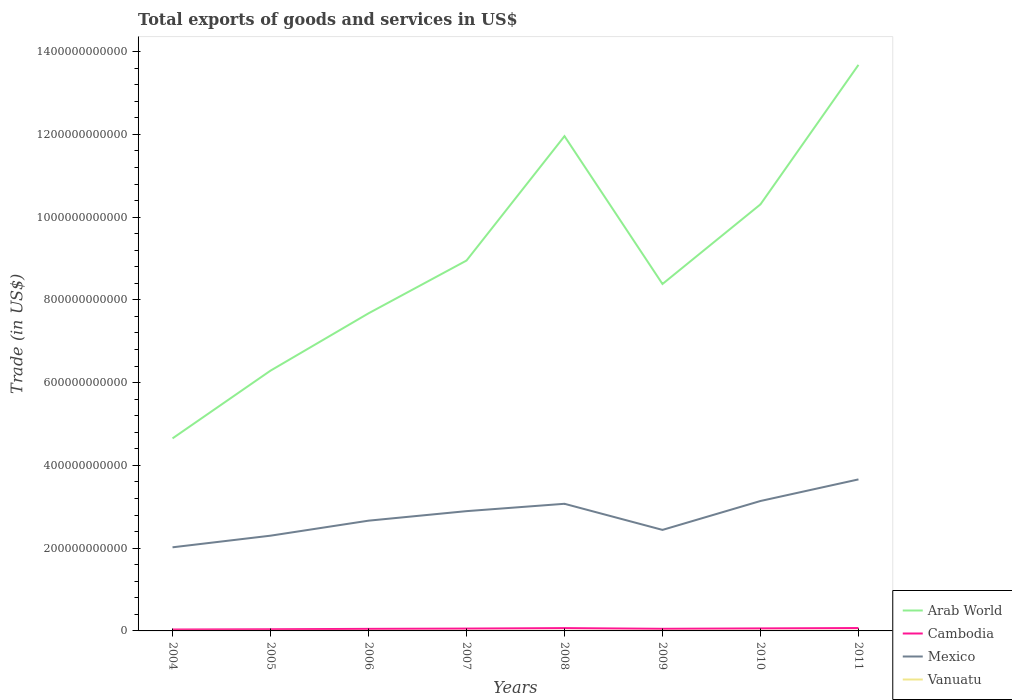Across all years, what is the maximum total exports of goods and services in Arab World?
Your answer should be very brief. 4.65e+11. In which year was the total exports of goods and services in Mexico maximum?
Your response must be concise. 2004. What is the total total exports of goods and services in Cambodia in the graph?
Keep it short and to the point. -1.53e+08. What is the difference between the highest and the second highest total exports of goods and services in Vanuatu?
Your answer should be very brief. 1.85e+08. Is the total exports of goods and services in Mexico strictly greater than the total exports of goods and services in Cambodia over the years?
Provide a succinct answer. No. What is the difference between two consecutive major ticks on the Y-axis?
Your answer should be very brief. 2.00e+11. Does the graph contain any zero values?
Your answer should be very brief. No. Does the graph contain grids?
Ensure brevity in your answer.  No. How many legend labels are there?
Ensure brevity in your answer.  4. How are the legend labels stacked?
Make the answer very short. Vertical. What is the title of the graph?
Make the answer very short. Total exports of goods and services in US$. Does "Egypt, Arab Rep." appear as one of the legend labels in the graph?
Keep it short and to the point. No. What is the label or title of the Y-axis?
Offer a very short reply. Trade (in US$). What is the Trade (in US$) in Arab World in 2004?
Provide a succinct answer. 4.65e+11. What is the Trade (in US$) of Cambodia in 2004?
Ensure brevity in your answer.  3.40e+09. What is the Trade (in US$) in Mexico in 2004?
Your answer should be very brief. 2.02e+11. What is the Trade (in US$) in Vanuatu in 2004?
Provide a succinct answer. 1.66e+08. What is the Trade (in US$) in Arab World in 2005?
Your answer should be compact. 6.29e+11. What is the Trade (in US$) of Cambodia in 2005?
Ensure brevity in your answer.  4.03e+09. What is the Trade (in US$) in Mexico in 2005?
Make the answer very short. 2.30e+11. What is the Trade (in US$) of Vanuatu in 2005?
Your answer should be very brief. 1.79e+08. What is the Trade (in US$) in Arab World in 2006?
Give a very brief answer. 7.67e+11. What is the Trade (in US$) in Cambodia in 2006?
Give a very brief answer. 4.99e+09. What is the Trade (in US$) of Mexico in 2006?
Offer a very short reply. 2.66e+11. What is the Trade (in US$) of Vanuatu in 2006?
Offer a terse response. 1.81e+08. What is the Trade (in US$) of Arab World in 2007?
Your answer should be very brief. 8.95e+11. What is the Trade (in US$) of Cambodia in 2007?
Make the answer very short. 5.64e+09. What is the Trade (in US$) of Mexico in 2007?
Provide a succinct answer. 2.89e+11. What is the Trade (in US$) in Vanuatu in 2007?
Ensure brevity in your answer.  2.15e+08. What is the Trade (in US$) of Arab World in 2008?
Offer a very short reply. 1.20e+12. What is the Trade (in US$) of Cambodia in 2008?
Keep it short and to the point. 6.78e+09. What is the Trade (in US$) in Mexico in 2008?
Provide a short and direct response. 3.07e+11. What is the Trade (in US$) of Vanuatu in 2008?
Give a very brief answer. 2.75e+08. What is the Trade (in US$) of Arab World in 2009?
Give a very brief answer. 8.38e+11. What is the Trade (in US$) in Cambodia in 2009?
Your answer should be compact. 5.12e+09. What is the Trade (in US$) of Mexico in 2009?
Provide a short and direct response. 2.44e+11. What is the Trade (in US$) of Vanuatu in 2009?
Offer a terse response. 3.00e+08. What is the Trade (in US$) in Arab World in 2010?
Keep it short and to the point. 1.03e+12. What is the Trade (in US$) of Cambodia in 2010?
Give a very brief answer. 6.08e+09. What is the Trade (in US$) of Mexico in 2010?
Provide a succinct answer. 3.14e+11. What is the Trade (in US$) in Vanuatu in 2010?
Make the answer very short. 3.27e+08. What is the Trade (in US$) in Arab World in 2011?
Ensure brevity in your answer.  1.37e+12. What is the Trade (in US$) in Cambodia in 2011?
Your answer should be very brief. 6.94e+09. What is the Trade (in US$) in Mexico in 2011?
Provide a short and direct response. 3.66e+11. What is the Trade (in US$) of Vanuatu in 2011?
Make the answer very short. 3.51e+08. Across all years, what is the maximum Trade (in US$) of Arab World?
Provide a short and direct response. 1.37e+12. Across all years, what is the maximum Trade (in US$) in Cambodia?
Give a very brief answer. 6.94e+09. Across all years, what is the maximum Trade (in US$) in Mexico?
Offer a very short reply. 3.66e+11. Across all years, what is the maximum Trade (in US$) in Vanuatu?
Keep it short and to the point. 3.51e+08. Across all years, what is the minimum Trade (in US$) in Arab World?
Your response must be concise. 4.65e+11. Across all years, what is the minimum Trade (in US$) of Cambodia?
Make the answer very short. 3.40e+09. Across all years, what is the minimum Trade (in US$) of Mexico?
Provide a succinct answer. 2.02e+11. Across all years, what is the minimum Trade (in US$) in Vanuatu?
Your answer should be compact. 1.66e+08. What is the total Trade (in US$) of Arab World in the graph?
Your response must be concise. 7.19e+12. What is the total Trade (in US$) of Cambodia in the graph?
Your answer should be very brief. 4.30e+1. What is the total Trade (in US$) in Mexico in the graph?
Your response must be concise. 2.22e+12. What is the total Trade (in US$) in Vanuatu in the graph?
Your answer should be compact. 1.99e+09. What is the difference between the Trade (in US$) of Arab World in 2004 and that in 2005?
Offer a terse response. -1.64e+11. What is the difference between the Trade (in US$) of Cambodia in 2004 and that in 2005?
Provide a short and direct response. -6.38e+08. What is the difference between the Trade (in US$) in Mexico in 2004 and that in 2005?
Ensure brevity in your answer.  -2.81e+1. What is the difference between the Trade (in US$) of Vanuatu in 2004 and that in 2005?
Offer a very short reply. -1.28e+07. What is the difference between the Trade (in US$) of Arab World in 2004 and that in 2006?
Ensure brevity in your answer.  -3.02e+11. What is the difference between the Trade (in US$) of Cambodia in 2004 and that in 2006?
Give a very brief answer. -1.59e+09. What is the difference between the Trade (in US$) in Mexico in 2004 and that in 2006?
Your answer should be compact. -6.44e+1. What is the difference between the Trade (in US$) of Vanuatu in 2004 and that in 2006?
Give a very brief answer. -1.49e+07. What is the difference between the Trade (in US$) in Arab World in 2004 and that in 2007?
Your answer should be compact. -4.30e+11. What is the difference between the Trade (in US$) in Cambodia in 2004 and that in 2007?
Provide a succinct answer. -2.25e+09. What is the difference between the Trade (in US$) in Mexico in 2004 and that in 2007?
Offer a very short reply. -8.74e+1. What is the difference between the Trade (in US$) of Vanuatu in 2004 and that in 2007?
Your response must be concise. -4.83e+07. What is the difference between the Trade (in US$) in Arab World in 2004 and that in 2008?
Ensure brevity in your answer.  -7.30e+11. What is the difference between the Trade (in US$) of Cambodia in 2004 and that in 2008?
Provide a succinct answer. -3.39e+09. What is the difference between the Trade (in US$) of Mexico in 2004 and that in 2008?
Keep it short and to the point. -1.05e+11. What is the difference between the Trade (in US$) in Vanuatu in 2004 and that in 2008?
Offer a very short reply. -1.08e+08. What is the difference between the Trade (in US$) of Arab World in 2004 and that in 2009?
Your answer should be very brief. -3.73e+11. What is the difference between the Trade (in US$) of Cambodia in 2004 and that in 2009?
Offer a terse response. -1.72e+09. What is the difference between the Trade (in US$) in Mexico in 2004 and that in 2009?
Your response must be concise. -4.21e+1. What is the difference between the Trade (in US$) in Vanuatu in 2004 and that in 2009?
Give a very brief answer. -1.33e+08. What is the difference between the Trade (in US$) in Arab World in 2004 and that in 2010?
Your answer should be very brief. -5.66e+11. What is the difference between the Trade (in US$) of Cambodia in 2004 and that in 2010?
Ensure brevity in your answer.  -2.68e+09. What is the difference between the Trade (in US$) of Mexico in 2004 and that in 2010?
Your answer should be compact. -1.12e+11. What is the difference between the Trade (in US$) of Vanuatu in 2004 and that in 2010?
Provide a short and direct response. -1.60e+08. What is the difference between the Trade (in US$) of Arab World in 2004 and that in 2011?
Provide a succinct answer. -9.03e+11. What is the difference between the Trade (in US$) in Cambodia in 2004 and that in 2011?
Your answer should be compact. -3.54e+09. What is the difference between the Trade (in US$) of Mexico in 2004 and that in 2011?
Give a very brief answer. -1.64e+11. What is the difference between the Trade (in US$) in Vanuatu in 2004 and that in 2011?
Make the answer very short. -1.85e+08. What is the difference between the Trade (in US$) of Arab World in 2005 and that in 2006?
Your answer should be compact. -1.39e+11. What is the difference between the Trade (in US$) in Cambodia in 2005 and that in 2006?
Your answer should be compact. -9.57e+08. What is the difference between the Trade (in US$) of Mexico in 2005 and that in 2006?
Keep it short and to the point. -3.63e+1. What is the difference between the Trade (in US$) in Vanuatu in 2005 and that in 2006?
Your answer should be very brief. -2.09e+06. What is the difference between the Trade (in US$) of Arab World in 2005 and that in 2007?
Offer a terse response. -2.66e+11. What is the difference between the Trade (in US$) in Cambodia in 2005 and that in 2007?
Make the answer very short. -1.61e+09. What is the difference between the Trade (in US$) of Mexico in 2005 and that in 2007?
Keep it short and to the point. -5.93e+1. What is the difference between the Trade (in US$) of Vanuatu in 2005 and that in 2007?
Provide a succinct answer. -3.55e+07. What is the difference between the Trade (in US$) of Arab World in 2005 and that in 2008?
Make the answer very short. -5.67e+11. What is the difference between the Trade (in US$) in Cambodia in 2005 and that in 2008?
Give a very brief answer. -2.75e+09. What is the difference between the Trade (in US$) of Mexico in 2005 and that in 2008?
Your answer should be compact. -7.71e+1. What is the difference between the Trade (in US$) of Vanuatu in 2005 and that in 2008?
Your answer should be very brief. -9.53e+07. What is the difference between the Trade (in US$) of Arab World in 2005 and that in 2009?
Offer a very short reply. -2.09e+11. What is the difference between the Trade (in US$) in Cambodia in 2005 and that in 2009?
Your response must be concise. -1.09e+09. What is the difference between the Trade (in US$) of Mexico in 2005 and that in 2009?
Make the answer very short. -1.40e+1. What is the difference between the Trade (in US$) in Vanuatu in 2005 and that in 2009?
Your response must be concise. -1.20e+08. What is the difference between the Trade (in US$) of Arab World in 2005 and that in 2010?
Provide a short and direct response. -4.02e+11. What is the difference between the Trade (in US$) of Cambodia in 2005 and that in 2010?
Your response must be concise. -2.05e+09. What is the difference between the Trade (in US$) in Mexico in 2005 and that in 2010?
Make the answer very short. -8.38e+1. What is the difference between the Trade (in US$) of Vanuatu in 2005 and that in 2010?
Provide a succinct answer. -1.48e+08. What is the difference between the Trade (in US$) of Arab World in 2005 and that in 2011?
Make the answer very short. -7.39e+11. What is the difference between the Trade (in US$) in Cambodia in 2005 and that in 2011?
Keep it short and to the point. -2.91e+09. What is the difference between the Trade (in US$) in Mexico in 2005 and that in 2011?
Provide a succinct answer. -1.36e+11. What is the difference between the Trade (in US$) in Vanuatu in 2005 and that in 2011?
Offer a terse response. -1.72e+08. What is the difference between the Trade (in US$) in Arab World in 2006 and that in 2007?
Offer a terse response. -1.28e+11. What is the difference between the Trade (in US$) of Cambodia in 2006 and that in 2007?
Your answer should be very brief. -6.54e+08. What is the difference between the Trade (in US$) in Mexico in 2006 and that in 2007?
Your answer should be very brief. -2.30e+1. What is the difference between the Trade (in US$) in Vanuatu in 2006 and that in 2007?
Provide a succinct answer. -3.34e+07. What is the difference between the Trade (in US$) in Arab World in 2006 and that in 2008?
Ensure brevity in your answer.  -4.28e+11. What is the difference between the Trade (in US$) in Cambodia in 2006 and that in 2008?
Offer a terse response. -1.80e+09. What is the difference between the Trade (in US$) of Mexico in 2006 and that in 2008?
Your response must be concise. -4.08e+1. What is the difference between the Trade (in US$) in Vanuatu in 2006 and that in 2008?
Provide a short and direct response. -9.32e+07. What is the difference between the Trade (in US$) of Arab World in 2006 and that in 2009?
Your answer should be very brief. -7.09e+1. What is the difference between the Trade (in US$) in Cambodia in 2006 and that in 2009?
Offer a very short reply. -1.30e+08. What is the difference between the Trade (in US$) of Mexico in 2006 and that in 2009?
Make the answer very short. 2.23e+1. What is the difference between the Trade (in US$) of Vanuatu in 2006 and that in 2009?
Provide a succinct answer. -1.18e+08. What is the difference between the Trade (in US$) of Arab World in 2006 and that in 2010?
Offer a very short reply. -2.63e+11. What is the difference between the Trade (in US$) in Cambodia in 2006 and that in 2010?
Provide a short and direct response. -1.09e+09. What is the difference between the Trade (in US$) of Mexico in 2006 and that in 2010?
Provide a succinct answer. -4.76e+1. What is the difference between the Trade (in US$) in Vanuatu in 2006 and that in 2010?
Your answer should be compact. -1.45e+08. What is the difference between the Trade (in US$) of Arab World in 2006 and that in 2011?
Your response must be concise. -6.00e+11. What is the difference between the Trade (in US$) in Cambodia in 2006 and that in 2011?
Keep it short and to the point. -1.95e+09. What is the difference between the Trade (in US$) in Mexico in 2006 and that in 2011?
Ensure brevity in your answer.  -9.97e+1. What is the difference between the Trade (in US$) of Vanuatu in 2006 and that in 2011?
Your answer should be very brief. -1.70e+08. What is the difference between the Trade (in US$) in Arab World in 2007 and that in 2008?
Offer a terse response. -3.01e+11. What is the difference between the Trade (in US$) of Cambodia in 2007 and that in 2008?
Your answer should be compact. -1.14e+09. What is the difference between the Trade (in US$) of Mexico in 2007 and that in 2008?
Offer a terse response. -1.78e+1. What is the difference between the Trade (in US$) of Vanuatu in 2007 and that in 2008?
Make the answer very short. -5.98e+07. What is the difference between the Trade (in US$) in Arab World in 2007 and that in 2009?
Offer a very short reply. 5.66e+1. What is the difference between the Trade (in US$) of Cambodia in 2007 and that in 2009?
Make the answer very short. 5.24e+08. What is the difference between the Trade (in US$) of Mexico in 2007 and that in 2009?
Provide a short and direct response. 4.53e+1. What is the difference between the Trade (in US$) in Vanuatu in 2007 and that in 2009?
Keep it short and to the point. -8.48e+07. What is the difference between the Trade (in US$) of Arab World in 2007 and that in 2010?
Offer a terse response. -1.36e+11. What is the difference between the Trade (in US$) of Cambodia in 2007 and that in 2010?
Provide a succinct answer. -4.36e+08. What is the difference between the Trade (in US$) in Mexico in 2007 and that in 2010?
Offer a terse response. -2.45e+1. What is the difference between the Trade (in US$) in Vanuatu in 2007 and that in 2010?
Provide a short and direct response. -1.12e+08. What is the difference between the Trade (in US$) of Arab World in 2007 and that in 2011?
Provide a succinct answer. -4.73e+11. What is the difference between the Trade (in US$) in Cambodia in 2007 and that in 2011?
Offer a very short reply. -1.29e+09. What is the difference between the Trade (in US$) in Mexico in 2007 and that in 2011?
Keep it short and to the point. -7.67e+1. What is the difference between the Trade (in US$) of Vanuatu in 2007 and that in 2011?
Offer a terse response. -1.36e+08. What is the difference between the Trade (in US$) of Arab World in 2008 and that in 2009?
Provide a short and direct response. 3.57e+11. What is the difference between the Trade (in US$) of Cambodia in 2008 and that in 2009?
Provide a short and direct response. 1.67e+09. What is the difference between the Trade (in US$) in Mexico in 2008 and that in 2009?
Ensure brevity in your answer.  6.31e+1. What is the difference between the Trade (in US$) in Vanuatu in 2008 and that in 2009?
Keep it short and to the point. -2.50e+07. What is the difference between the Trade (in US$) of Arab World in 2008 and that in 2010?
Your answer should be compact. 1.65e+11. What is the difference between the Trade (in US$) in Cambodia in 2008 and that in 2010?
Ensure brevity in your answer.  7.05e+08. What is the difference between the Trade (in US$) of Mexico in 2008 and that in 2010?
Your answer should be compact. -6.75e+09. What is the difference between the Trade (in US$) of Vanuatu in 2008 and that in 2010?
Keep it short and to the point. -5.22e+07. What is the difference between the Trade (in US$) of Arab World in 2008 and that in 2011?
Offer a very short reply. -1.72e+11. What is the difference between the Trade (in US$) of Cambodia in 2008 and that in 2011?
Give a very brief answer. -1.53e+08. What is the difference between the Trade (in US$) of Mexico in 2008 and that in 2011?
Make the answer very short. -5.89e+1. What is the difference between the Trade (in US$) in Vanuatu in 2008 and that in 2011?
Your answer should be compact. -7.67e+07. What is the difference between the Trade (in US$) in Arab World in 2009 and that in 2010?
Offer a terse response. -1.92e+11. What is the difference between the Trade (in US$) in Cambodia in 2009 and that in 2010?
Offer a terse response. -9.60e+08. What is the difference between the Trade (in US$) in Mexico in 2009 and that in 2010?
Ensure brevity in your answer.  -6.98e+1. What is the difference between the Trade (in US$) of Vanuatu in 2009 and that in 2010?
Provide a succinct answer. -2.72e+07. What is the difference between the Trade (in US$) of Arab World in 2009 and that in 2011?
Make the answer very short. -5.30e+11. What is the difference between the Trade (in US$) in Cambodia in 2009 and that in 2011?
Provide a short and direct response. -1.82e+09. What is the difference between the Trade (in US$) in Mexico in 2009 and that in 2011?
Keep it short and to the point. -1.22e+11. What is the difference between the Trade (in US$) in Vanuatu in 2009 and that in 2011?
Your response must be concise. -5.16e+07. What is the difference between the Trade (in US$) in Arab World in 2010 and that in 2011?
Your answer should be very brief. -3.37e+11. What is the difference between the Trade (in US$) of Cambodia in 2010 and that in 2011?
Ensure brevity in your answer.  -8.58e+08. What is the difference between the Trade (in US$) in Mexico in 2010 and that in 2011?
Give a very brief answer. -5.22e+1. What is the difference between the Trade (in US$) in Vanuatu in 2010 and that in 2011?
Offer a very short reply. -2.45e+07. What is the difference between the Trade (in US$) in Arab World in 2004 and the Trade (in US$) in Cambodia in 2005?
Provide a succinct answer. 4.61e+11. What is the difference between the Trade (in US$) in Arab World in 2004 and the Trade (in US$) in Mexico in 2005?
Your answer should be very brief. 2.35e+11. What is the difference between the Trade (in US$) of Arab World in 2004 and the Trade (in US$) of Vanuatu in 2005?
Offer a terse response. 4.65e+11. What is the difference between the Trade (in US$) in Cambodia in 2004 and the Trade (in US$) in Mexico in 2005?
Keep it short and to the point. -2.27e+11. What is the difference between the Trade (in US$) of Cambodia in 2004 and the Trade (in US$) of Vanuatu in 2005?
Provide a short and direct response. 3.22e+09. What is the difference between the Trade (in US$) of Mexico in 2004 and the Trade (in US$) of Vanuatu in 2005?
Your answer should be compact. 2.02e+11. What is the difference between the Trade (in US$) of Arab World in 2004 and the Trade (in US$) of Cambodia in 2006?
Offer a terse response. 4.60e+11. What is the difference between the Trade (in US$) of Arab World in 2004 and the Trade (in US$) of Mexico in 2006?
Your answer should be compact. 1.99e+11. What is the difference between the Trade (in US$) in Arab World in 2004 and the Trade (in US$) in Vanuatu in 2006?
Ensure brevity in your answer.  4.65e+11. What is the difference between the Trade (in US$) of Cambodia in 2004 and the Trade (in US$) of Mexico in 2006?
Offer a very short reply. -2.63e+11. What is the difference between the Trade (in US$) of Cambodia in 2004 and the Trade (in US$) of Vanuatu in 2006?
Make the answer very short. 3.21e+09. What is the difference between the Trade (in US$) of Mexico in 2004 and the Trade (in US$) of Vanuatu in 2006?
Your answer should be compact. 2.02e+11. What is the difference between the Trade (in US$) of Arab World in 2004 and the Trade (in US$) of Cambodia in 2007?
Offer a terse response. 4.60e+11. What is the difference between the Trade (in US$) of Arab World in 2004 and the Trade (in US$) of Mexico in 2007?
Offer a terse response. 1.76e+11. What is the difference between the Trade (in US$) of Arab World in 2004 and the Trade (in US$) of Vanuatu in 2007?
Offer a terse response. 4.65e+11. What is the difference between the Trade (in US$) in Cambodia in 2004 and the Trade (in US$) in Mexico in 2007?
Offer a very short reply. -2.86e+11. What is the difference between the Trade (in US$) in Cambodia in 2004 and the Trade (in US$) in Vanuatu in 2007?
Offer a very short reply. 3.18e+09. What is the difference between the Trade (in US$) of Mexico in 2004 and the Trade (in US$) of Vanuatu in 2007?
Your answer should be compact. 2.02e+11. What is the difference between the Trade (in US$) of Arab World in 2004 and the Trade (in US$) of Cambodia in 2008?
Offer a terse response. 4.58e+11. What is the difference between the Trade (in US$) of Arab World in 2004 and the Trade (in US$) of Mexico in 2008?
Provide a short and direct response. 1.58e+11. What is the difference between the Trade (in US$) of Arab World in 2004 and the Trade (in US$) of Vanuatu in 2008?
Give a very brief answer. 4.65e+11. What is the difference between the Trade (in US$) of Cambodia in 2004 and the Trade (in US$) of Mexico in 2008?
Provide a succinct answer. -3.04e+11. What is the difference between the Trade (in US$) in Cambodia in 2004 and the Trade (in US$) in Vanuatu in 2008?
Your answer should be very brief. 3.12e+09. What is the difference between the Trade (in US$) in Mexico in 2004 and the Trade (in US$) in Vanuatu in 2008?
Give a very brief answer. 2.02e+11. What is the difference between the Trade (in US$) of Arab World in 2004 and the Trade (in US$) of Cambodia in 2009?
Offer a terse response. 4.60e+11. What is the difference between the Trade (in US$) of Arab World in 2004 and the Trade (in US$) of Mexico in 2009?
Ensure brevity in your answer.  2.21e+11. What is the difference between the Trade (in US$) of Arab World in 2004 and the Trade (in US$) of Vanuatu in 2009?
Keep it short and to the point. 4.65e+11. What is the difference between the Trade (in US$) in Cambodia in 2004 and the Trade (in US$) in Mexico in 2009?
Keep it short and to the point. -2.41e+11. What is the difference between the Trade (in US$) of Cambodia in 2004 and the Trade (in US$) of Vanuatu in 2009?
Your answer should be compact. 3.10e+09. What is the difference between the Trade (in US$) in Mexico in 2004 and the Trade (in US$) in Vanuatu in 2009?
Your answer should be very brief. 2.02e+11. What is the difference between the Trade (in US$) in Arab World in 2004 and the Trade (in US$) in Cambodia in 2010?
Make the answer very short. 4.59e+11. What is the difference between the Trade (in US$) of Arab World in 2004 and the Trade (in US$) of Mexico in 2010?
Your answer should be very brief. 1.51e+11. What is the difference between the Trade (in US$) of Arab World in 2004 and the Trade (in US$) of Vanuatu in 2010?
Give a very brief answer. 4.65e+11. What is the difference between the Trade (in US$) in Cambodia in 2004 and the Trade (in US$) in Mexico in 2010?
Provide a succinct answer. -3.11e+11. What is the difference between the Trade (in US$) in Cambodia in 2004 and the Trade (in US$) in Vanuatu in 2010?
Keep it short and to the point. 3.07e+09. What is the difference between the Trade (in US$) of Mexico in 2004 and the Trade (in US$) of Vanuatu in 2010?
Your response must be concise. 2.02e+11. What is the difference between the Trade (in US$) of Arab World in 2004 and the Trade (in US$) of Cambodia in 2011?
Make the answer very short. 4.58e+11. What is the difference between the Trade (in US$) of Arab World in 2004 and the Trade (in US$) of Mexico in 2011?
Provide a succinct answer. 9.91e+1. What is the difference between the Trade (in US$) in Arab World in 2004 and the Trade (in US$) in Vanuatu in 2011?
Offer a terse response. 4.65e+11. What is the difference between the Trade (in US$) in Cambodia in 2004 and the Trade (in US$) in Mexico in 2011?
Your response must be concise. -3.63e+11. What is the difference between the Trade (in US$) in Cambodia in 2004 and the Trade (in US$) in Vanuatu in 2011?
Your answer should be very brief. 3.04e+09. What is the difference between the Trade (in US$) in Mexico in 2004 and the Trade (in US$) in Vanuatu in 2011?
Your answer should be compact. 2.02e+11. What is the difference between the Trade (in US$) of Arab World in 2005 and the Trade (in US$) of Cambodia in 2006?
Give a very brief answer. 6.24e+11. What is the difference between the Trade (in US$) in Arab World in 2005 and the Trade (in US$) in Mexico in 2006?
Keep it short and to the point. 3.63e+11. What is the difference between the Trade (in US$) of Arab World in 2005 and the Trade (in US$) of Vanuatu in 2006?
Ensure brevity in your answer.  6.29e+11. What is the difference between the Trade (in US$) in Cambodia in 2005 and the Trade (in US$) in Mexico in 2006?
Offer a terse response. -2.62e+11. What is the difference between the Trade (in US$) of Cambodia in 2005 and the Trade (in US$) of Vanuatu in 2006?
Your answer should be very brief. 3.85e+09. What is the difference between the Trade (in US$) in Mexico in 2005 and the Trade (in US$) in Vanuatu in 2006?
Keep it short and to the point. 2.30e+11. What is the difference between the Trade (in US$) of Arab World in 2005 and the Trade (in US$) of Cambodia in 2007?
Keep it short and to the point. 6.23e+11. What is the difference between the Trade (in US$) in Arab World in 2005 and the Trade (in US$) in Mexico in 2007?
Your answer should be compact. 3.40e+11. What is the difference between the Trade (in US$) of Arab World in 2005 and the Trade (in US$) of Vanuatu in 2007?
Your answer should be very brief. 6.29e+11. What is the difference between the Trade (in US$) of Cambodia in 2005 and the Trade (in US$) of Mexico in 2007?
Your response must be concise. -2.85e+11. What is the difference between the Trade (in US$) in Cambodia in 2005 and the Trade (in US$) in Vanuatu in 2007?
Keep it short and to the point. 3.82e+09. What is the difference between the Trade (in US$) in Mexico in 2005 and the Trade (in US$) in Vanuatu in 2007?
Your response must be concise. 2.30e+11. What is the difference between the Trade (in US$) of Arab World in 2005 and the Trade (in US$) of Cambodia in 2008?
Offer a very short reply. 6.22e+11. What is the difference between the Trade (in US$) in Arab World in 2005 and the Trade (in US$) in Mexico in 2008?
Offer a very short reply. 3.22e+11. What is the difference between the Trade (in US$) in Arab World in 2005 and the Trade (in US$) in Vanuatu in 2008?
Make the answer very short. 6.29e+11. What is the difference between the Trade (in US$) of Cambodia in 2005 and the Trade (in US$) of Mexico in 2008?
Offer a terse response. -3.03e+11. What is the difference between the Trade (in US$) of Cambodia in 2005 and the Trade (in US$) of Vanuatu in 2008?
Your answer should be compact. 3.76e+09. What is the difference between the Trade (in US$) of Mexico in 2005 and the Trade (in US$) of Vanuatu in 2008?
Provide a short and direct response. 2.30e+11. What is the difference between the Trade (in US$) of Arab World in 2005 and the Trade (in US$) of Cambodia in 2009?
Provide a short and direct response. 6.24e+11. What is the difference between the Trade (in US$) of Arab World in 2005 and the Trade (in US$) of Mexico in 2009?
Provide a short and direct response. 3.85e+11. What is the difference between the Trade (in US$) of Arab World in 2005 and the Trade (in US$) of Vanuatu in 2009?
Provide a short and direct response. 6.29e+11. What is the difference between the Trade (in US$) in Cambodia in 2005 and the Trade (in US$) in Mexico in 2009?
Your answer should be compact. -2.40e+11. What is the difference between the Trade (in US$) in Cambodia in 2005 and the Trade (in US$) in Vanuatu in 2009?
Make the answer very short. 3.73e+09. What is the difference between the Trade (in US$) of Mexico in 2005 and the Trade (in US$) of Vanuatu in 2009?
Your answer should be very brief. 2.30e+11. What is the difference between the Trade (in US$) of Arab World in 2005 and the Trade (in US$) of Cambodia in 2010?
Your answer should be very brief. 6.23e+11. What is the difference between the Trade (in US$) of Arab World in 2005 and the Trade (in US$) of Mexico in 2010?
Provide a succinct answer. 3.15e+11. What is the difference between the Trade (in US$) of Arab World in 2005 and the Trade (in US$) of Vanuatu in 2010?
Provide a succinct answer. 6.29e+11. What is the difference between the Trade (in US$) in Cambodia in 2005 and the Trade (in US$) in Mexico in 2010?
Your answer should be compact. -3.10e+11. What is the difference between the Trade (in US$) in Cambodia in 2005 and the Trade (in US$) in Vanuatu in 2010?
Make the answer very short. 3.71e+09. What is the difference between the Trade (in US$) in Mexico in 2005 and the Trade (in US$) in Vanuatu in 2010?
Offer a very short reply. 2.30e+11. What is the difference between the Trade (in US$) of Arab World in 2005 and the Trade (in US$) of Cambodia in 2011?
Your answer should be very brief. 6.22e+11. What is the difference between the Trade (in US$) in Arab World in 2005 and the Trade (in US$) in Mexico in 2011?
Keep it short and to the point. 2.63e+11. What is the difference between the Trade (in US$) of Arab World in 2005 and the Trade (in US$) of Vanuatu in 2011?
Ensure brevity in your answer.  6.29e+11. What is the difference between the Trade (in US$) in Cambodia in 2005 and the Trade (in US$) in Mexico in 2011?
Your response must be concise. -3.62e+11. What is the difference between the Trade (in US$) of Cambodia in 2005 and the Trade (in US$) of Vanuatu in 2011?
Provide a succinct answer. 3.68e+09. What is the difference between the Trade (in US$) of Mexico in 2005 and the Trade (in US$) of Vanuatu in 2011?
Your response must be concise. 2.30e+11. What is the difference between the Trade (in US$) in Arab World in 2006 and the Trade (in US$) in Cambodia in 2007?
Your answer should be compact. 7.62e+11. What is the difference between the Trade (in US$) of Arab World in 2006 and the Trade (in US$) of Mexico in 2007?
Provide a short and direct response. 4.78e+11. What is the difference between the Trade (in US$) of Arab World in 2006 and the Trade (in US$) of Vanuatu in 2007?
Your answer should be compact. 7.67e+11. What is the difference between the Trade (in US$) of Cambodia in 2006 and the Trade (in US$) of Mexico in 2007?
Your answer should be very brief. -2.84e+11. What is the difference between the Trade (in US$) of Cambodia in 2006 and the Trade (in US$) of Vanuatu in 2007?
Provide a succinct answer. 4.78e+09. What is the difference between the Trade (in US$) of Mexico in 2006 and the Trade (in US$) of Vanuatu in 2007?
Offer a very short reply. 2.66e+11. What is the difference between the Trade (in US$) of Arab World in 2006 and the Trade (in US$) of Cambodia in 2008?
Ensure brevity in your answer.  7.61e+11. What is the difference between the Trade (in US$) in Arab World in 2006 and the Trade (in US$) in Mexico in 2008?
Keep it short and to the point. 4.60e+11. What is the difference between the Trade (in US$) in Arab World in 2006 and the Trade (in US$) in Vanuatu in 2008?
Ensure brevity in your answer.  7.67e+11. What is the difference between the Trade (in US$) in Cambodia in 2006 and the Trade (in US$) in Mexico in 2008?
Your answer should be very brief. -3.02e+11. What is the difference between the Trade (in US$) of Cambodia in 2006 and the Trade (in US$) of Vanuatu in 2008?
Offer a very short reply. 4.72e+09. What is the difference between the Trade (in US$) of Mexico in 2006 and the Trade (in US$) of Vanuatu in 2008?
Provide a short and direct response. 2.66e+11. What is the difference between the Trade (in US$) in Arab World in 2006 and the Trade (in US$) in Cambodia in 2009?
Provide a short and direct response. 7.62e+11. What is the difference between the Trade (in US$) in Arab World in 2006 and the Trade (in US$) in Mexico in 2009?
Provide a succinct answer. 5.23e+11. What is the difference between the Trade (in US$) of Arab World in 2006 and the Trade (in US$) of Vanuatu in 2009?
Provide a succinct answer. 7.67e+11. What is the difference between the Trade (in US$) of Cambodia in 2006 and the Trade (in US$) of Mexico in 2009?
Make the answer very short. -2.39e+11. What is the difference between the Trade (in US$) of Cambodia in 2006 and the Trade (in US$) of Vanuatu in 2009?
Your response must be concise. 4.69e+09. What is the difference between the Trade (in US$) in Mexico in 2006 and the Trade (in US$) in Vanuatu in 2009?
Give a very brief answer. 2.66e+11. What is the difference between the Trade (in US$) of Arab World in 2006 and the Trade (in US$) of Cambodia in 2010?
Provide a succinct answer. 7.61e+11. What is the difference between the Trade (in US$) of Arab World in 2006 and the Trade (in US$) of Mexico in 2010?
Your answer should be compact. 4.53e+11. What is the difference between the Trade (in US$) of Arab World in 2006 and the Trade (in US$) of Vanuatu in 2010?
Your response must be concise. 7.67e+11. What is the difference between the Trade (in US$) in Cambodia in 2006 and the Trade (in US$) in Mexico in 2010?
Give a very brief answer. -3.09e+11. What is the difference between the Trade (in US$) in Cambodia in 2006 and the Trade (in US$) in Vanuatu in 2010?
Offer a terse response. 4.66e+09. What is the difference between the Trade (in US$) of Mexico in 2006 and the Trade (in US$) of Vanuatu in 2010?
Give a very brief answer. 2.66e+11. What is the difference between the Trade (in US$) of Arab World in 2006 and the Trade (in US$) of Cambodia in 2011?
Give a very brief answer. 7.61e+11. What is the difference between the Trade (in US$) in Arab World in 2006 and the Trade (in US$) in Mexico in 2011?
Your answer should be compact. 4.01e+11. What is the difference between the Trade (in US$) in Arab World in 2006 and the Trade (in US$) in Vanuatu in 2011?
Make the answer very short. 7.67e+11. What is the difference between the Trade (in US$) in Cambodia in 2006 and the Trade (in US$) in Mexico in 2011?
Provide a short and direct response. -3.61e+11. What is the difference between the Trade (in US$) in Cambodia in 2006 and the Trade (in US$) in Vanuatu in 2011?
Provide a short and direct response. 4.64e+09. What is the difference between the Trade (in US$) in Mexico in 2006 and the Trade (in US$) in Vanuatu in 2011?
Your answer should be very brief. 2.66e+11. What is the difference between the Trade (in US$) of Arab World in 2007 and the Trade (in US$) of Cambodia in 2008?
Your response must be concise. 8.88e+11. What is the difference between the Trade (in US$) of Arab World in 2007 and the Trade (in US$) of Mexico in 2008?
Your answer should be compact. 5.88e+11. What is the difference between the Trade (in US$) of Arab World in 2007 and the Trade (in US$) of Vanuatu in 2008?
Keep it short and to the point. 8.95e+11. What is the difference between the Trade (in US$) of Cambodia in 2007 and the Trade (in US$) of Mexico in 2008?
Keep it short and to the point. -3.02e+11. What is the difference between the Trade (in US$) in Cambodia in 2007 and the Trade (in US$) in Vanuatu in 2008?
Offer a terse response. 5.37e+09. What is the difference between the Trade (in US$) of Mexico in 2007 and the Trade (in US$) of Vanuatu in 2008?
Your answer should be very brief. 2.89e+11. What is the difference between the Trade (in US$) of Arab World in 2007 and the Trade (in US$) of Cambodia in 2009?
Ensure brevity in your answer.  8.90e+11. What is the difference between the Trade (in US$) in Arab World in 2007 and the Trade (in US$) in Mexico in 2009?
Your answer should be compact. 6.51e+11. What is the difference between the Trade (in US$) in Arab World in 2007 and the Trade (in US$) in Vanuatu in 2009?
Your response must be concise. 8.95e+11. What is the difference between the Trade (in US$) of Cambodia in 2007 and the Trade (in US$) of Mexico in 2009?
Ensure brevity in your answer.  -2.39e+11. What is the difference between the Trade (in US$) in Cambodia in 2007 and the Trade (in US$) in Vanuatu in 2009?
Your answer should be compact. 5.34e+09. What is the difference between the Trade (in US$) of Mexico in 2007 and the Trade (in US$) of Vanuatu in 2009?
Your answer should be compact. 2.89e+11. What is the difference between the Trade (in US$) of Arab World in 2007 and the Trade (in US$) of Cambodia in 2010?
Your response must be concise. 8.89e+11. What is the difference between the Trade (in US$) in Arab World in 2007 and the Trade (in US$) in Mexico in 2010?
Your answer should be compact. 5.81e+11. What is the difference between the Trade (in US$) in Arab World in 2007 and the Trade (in US$) in Vanuatu in 2010?
Make the answer very short. 8.95e+11. What is the difference between the Trade (in US$) in Cambodia in 2007 and the Trade (in US$) in Mexico in 2010?
Keep it short and to the point. -3.08e+11. What is the difference between the Trade (in US$) in Cambodia in 2007 and the Trade (in US$) in Vanuatu in 2010?
Provide a succinct answer. 5.32e+09. What is the difference between the Trade (in US$) in Mexico in 2007 and the Trade (in US$) in Vanuatu in 2010?
Offer a terse response. 2.89e+11. What is the difference between the Trade (in US$) of Arab World in 2007 and the Trade (in US$) of Cambodia in 2011?
Your response must be concise. 8.88e+11. What is the difference between the Trade (in US$) of Arab World in 2007 and the Trade (in US$) of Mexico in 2011?
Offer a terse response. 5.29e+11. What is the difference between the Trade (in US$) of Arab World in 2007 and the Trade (in US$) of Vanuatu in 2011?
Provide a short and direct response. 8.95e+11. What is the difference between the Trade (in US$) in Cambodia in 2007 and the Trade (in US$) in Mexico in 2011?
Provide a short and direct response. -3.61e+11. What is the difference between the Trade (in US$) in Cambodia in 2007 and the Trade (in US$) in Vanuatu in 2011?
Your answer should be compact. 5.29e+09. What is the difference between the Trade (in US$) in Mexico in 2007 and the Trade (in US$) in Vanuatu in 2011?
Provide a succinct answer. 2.89e+11. What is the difference between the Trade (in US$) in Arab World in 2008 and the Trade (in US$) in Cambodia in 2009?
Offer a very short reply. 1.19e+12. What is the difference between the Trade (in US$) in Arab World in 2008 and the Trade (in US$) in Mexico in 2009?
Give a very brief answer. 9.52e+11. What is the difference between the Trade (in US$) of Arab World in 2008 and the Trade (in US$) of Vanuatu in 2009?
Give a very brief answer. 1.20e+12. What is the difference between the Trade (in US$) of Cambodia in 2008 and the Trade (in US$) of Mexico in 2009?
Ensure brevity in your answer.  -2.37e+11. What is the difference between the Trade (in US$) in Cambodia in 2008 and the Trade (in US$) in Vanuatu in 2009?
Your answer should be very brief. 6.49e+09. What is the difference between the Trade (in US$) in Mexico in 2008 and the Trade (in US$) in Vanuatu in 2009?
Ensure brevity in your answer.  3.07e+11. What is the difference between the Trade (in US$) of Arab World in 2008 and the Trade (in US$) of Cambodia in 2010?
Your response must be concise. 1.19e+12. What is the difference between the Trade (in US$) of Arab World in 2008 and the Trade (in US$) of Mexico in 2010?
Provide a short and direct response. 8.82e+11. What is the difference between the Trade (in US$) of Arab World in 2008 and the Trade (in US$) of Vanuatu in 2010?
Offer a very short reply. 1.20e+12. What is the difference between the Trade (in US$) of Cambodia in 2008 and the Trade (in US$) of Mexico in 2010?
Provide a short and direct response. -3.07e+11. What is the difference between the Trade (in US$) in Cambodia in 2008 and the Trade (in US$) in Vanuatu in 2010?
Make the answer very short. 6.46e+09. What is the difference between the Trade (in US$) in Mexico in 2008 and the Trade (in US$) in Vanuatu in 2010?
Your answer should be compact. 3.07e+11. What is the difference between the Trade (in US$) in Arab World in 2008 and the Trade (in US$) in Cambodia in 2011?
Keep it short and to the point. 1.19e+12. What is the difference between the Trade (in US$) of Arab World in 2008 and the Trade (in US$) of Mexico in 2011?
Your answer should be very brief. 8.29e+11. What is the difference between the Trade (in US$) of Arab World in 2008 and the Trade (in US$) of Vanuatu in 2011?
Ensure brevity in your answer.  1.20e+12. What is the difference between the Trade (in US$) in Cambodia in 2008 and the Trade (in US$) in Mexico in 2011?
Give a very brief answer. -3.59e+11. What is the difference between the Trade (in US$) in Cambodia in 2008 and the Trade (in US$) in Vanuatu in 2011?
Give a very brief answer. 6.43e+09. What is the difference between the Trade (in US$) in Mexico in 2008 and the Trade (in US$) in Vanuatu in 2011?
Ensure brevity in your answer.  3.07e+11. What is the difference between the Trade (in US$) in Arab World in 2009 and the Trade (in US$) in Cambodia in 2010?
Your response must be concise. 8.32e+11. What is the difference between the Trade (in US$) in Arab World in 2009 and the Trade (in US$) in Mexico in 2010?
Keep it short and to the point. 5.24e+11. What is the difference between the Trade (in US$) of Arab World in 2009 and the Trade (in US$) of Vanuatu in 2010?
Provide a succinct answer. 8.38e+11. What is the difference between the Trade (in US$) in Cambodia in 2009 and the Trade (in US$) in Mexico in 2010?
Your answer should be very brief. -3.09e+11. What is the difference between the Trade (in US$) of Cambodia in 2009 and the Trade (in US$) of Vanuatu in 2010?
Your answer should be compact. 4.79e+09. What is the difference between the Trade (in US$) in Mexico in 2009 and the Trade (in US$) in Vanuatu in 2010?
Provide a succinct answer. 2.44e+11. What is the difference between the Trade (in US$) of Arab World in 2009 and the Trade (in US$) of Cambodia in 2011?
Your answer should be very brief. 8.31e+11. What is the difference between the Trade (in US$) in Arab World in 2009 and the Trade (in US$) in Mexico in 2011?
Your answer should be very brief. 4.72e+11. What is the difference between the Trade (in US$) in Arab World in 2009 and the Trade (in US$) in Vanuatu in 2011?
Keep it short and to the point. 8.38e+11. What is the difference between the Trade (in US$) of Cambodia in 2009 and the Trade (in US$) of Mexico in 2011?
Make the answer very short. -3.61e+11. What is the difference between the Trade (in US$) of Cambodia in 2009 and the Trade (in US$) of Vanuatu in 2011?
Give a very brief answer. 4.77e+09. What is the difference between the Trade (in US$) of Mexico in 2009 and the Trade (in US$) of Vanuatu in 2011?
Keep it short and to the point. 2.44e+11. What is the difference between the Trade (in US$) in Arab World in 2010 and the Trade (in US$) in Cambodia in 2011?
Offer a very short reply. 1.02e+12. What is the difference between the Trade (in US$) of Arab World in 2010 and the Trade (in US$) of Mexico in 2011?
Your answer should be compact. 6.65e+11. What is the difference between the Trade (in US$) of Arab World in 2010 and the Trade (in US$) of Vanuatu in 2011?
Your answer should be very brief. 1.03e+12. What is the difference between the Trade (in US$) of Cambodia in 2010 and the Trade (in US$) of Mexico in 2011?
Your answer should be compact. -3.60e+11. What is the difference between the Trade (in US$) of Cambodia in 2010 and the Trade (in US$) of Vanuatu in 2011?
Give a very brief answer. 5.73e+09. What is the difference between the Trade (in US$) of Mexico in 2010 and the Trade (in US$) of Vanuatu in 2011?
Your answer should be very brief. 3.14e+11. What is the average Trade (in US$) of Arab World per year?
Provide a short and direct response. 8.99e+11. What is the average Trade (in US$) of Cambodia per year?
Offer a very short reply. 5.37e+09. What is the average Trade (in US$) of Mexico per year?
Your answer should be very brief. 2.77e+11. What is the average Trade (in US$) in Vanuatu per year?
Your answer should be compact. 2.49e+08. In the year 2004, what is the difference between the Trade (in US$) in Arab World and Trade (in US$) in Cambodia?
Provide a succinct answer. 4.62e+11. In the year 2004, what is the difference between the Trade (in US$) of Arab World and Trade (in US$) of Mexico?
Give a very brief answer. 2.63e+11. In the year 2004, what is the difference between the Trade (in US$) in Arab World and Trade (in US$) in Vanuatu?
Offer a terse response. 4.65e+11. In the year 2004, what is the difference between the Trade (in US$) in Cambodia and Trade (in US$) in Mexico?
Your response must be concise. -1.99e+11. In the year 2004, what is the difference between the Trade (in US$) in Cambodia and Trade (in US$) in Vanuatu?
Offer a terse response. 3.23e+09. In the year 2004, what is the difference between the Trade (in US$) in Mexico and Trade (in US$) in Vanuatu?
Offer a terse response. 2.02e+11. In the year 2005, what is the difference between the Trade (in US$) in Arab World and Trade (in US$) in Cambodia?
Keep it short and to the point. 6.25e+11. In the year 2005, what is the difference between the Trade (in US$) in Arab World and Trade (in US$) in Mexico?
Offer a terse response. 3.99e+11. In the year 2005, what is the difference between the Trade (in US$) in Arab World and Trade (in US$) in Vanuatu?
Give a very brief answer. 6.29e+11. In the year 2005, what is the difference between the Trade (in US$) in Cambodia and Trade (in US$) in Mexico?
Ensure brevity in your answer.  -2.26e+11. In the year 2005, what is the difference between the Trade (in US$) of Cambodia and Trade (in US$) of Vanuatu?
Keep it short and to the point. 3.85e+09. In the year 2005, what is the difference between the Trade (in US$) in Mexico and Trade (in US$) in Vanuatu?
Offer a terse response. 2.30e+11. In the year 2006, what is the difference between the Trade (in US$) in Arab World and Trade (in US$) in Cambodia?
Keep it short and to the point. 7.62e+11. In the year 2006, what is the difference between the Trade (in US$) of Arab World and Trade (in US$) of Mexico?
Ensure brevity in your answer.  5.01e+11. In the year 2006, what is the difference between the Trade (in US$) in Arab World and Trade (in US$) in Vanuatu?
Ensure brevity in your answer.  7.67e+11. In the year 2006, what is the difference between the Trade (in US$) in Cambodia and Trade (in US$) in Mexico?
Ensure brevity in your answer.  -2.61e+11. In the year 2006, what is the difference between the Trade (in US$) in Cambodia and Trade (in US$) in Vanuatu?
Give a very brief answer. 4.81e+09. In the year 2006, what is the difference between the Trade (in US$) in Mexico and Trade (in US$) in Vanuatu?
Your response must be concise. 2.66e+11. In the year 2007, what is the difference between the Trade (in US$) of Arab World and Trade (in US$) of Cambodia?
Make the answer very short. 8.89e+11. In the year 2007, what is the difference between the Trade (in US$) of Arab World and Trade (in US$) of Mexico?
Your answer should be compact. 6.06e+11. In the year 2007, what is the difference between the Trade (in US$) in Arab World and Trade (in US$) in Vanuatu?
Your answer should be compact. 8.95e+11. In the year 2007, what is the difference between the Trade (in US$) of Cambodia and Trade (in US$) of Mexico?
Keep it short and to the point. -2.84e+11. In the year 2007, what is the difference between the Trade (in US$) of Cambodia and Trade (in US$) of Vanuatu?
Your answer should be compact. 5.43e+09. In the year 2007, what is the difference between the Trade (in US$) of Mexico and Trade (in US$) of Vanuatu?
Your answer should be compact. 2.89e+11. In the year 2008, what is the difference between the Trade (in US$) in Arab World and Trade (in US$) in Cambodia?
Give a very brief answer. 1.19e+12. In the year 2008, what is the difference between the Trade (in US$) of Arab World and Trade (in US$) of Mexico?
Keep it short and to the point. 8.88e+11. In the year 2008, what is the difference between the Trade (in US$) of Arab World and Trade (in US$) of Vanuatu?
Keep it short and to the point. 1.20e+12. In the year 2008, what is the difference between the Trade (in US$) of Cambodia and Trade (in US$) of Mexico?
Make the answer very short. -3.00e+11. In the year 2008, what is the difference between the Trade (in US$) in Cambodia and Trade (in US$) in Vanuatu?
Your answer should be very brief. 6.51e+09. In the year 2008, what is the difference between the Trade (in US$) of Mexico and Trade (in US$) of Vanuatu?
Ensure brevity in your answer.  3.07e+11. In the year 2009, what is the difference between the Trade (in US$) of Arab World and Trade (in US$) of Cambodia?
Your answer should be compact. 8.33e+11. In the year 2009, what is the difference between the Trade (in US$) of Arab World and Trade (in US$) of Mexico?
Keep it short and to the point. 5.94e+11. In the year 2009, what is the difference between the Trade (in US$) of Arab World and Trade (in US$) of Vanuatu?
Offer a terse response. 8.38e+11. In the year 2009, what is the difference between the Trade (in US$) in Cambodia and Trade (in US$) in Mexico?
Offer a terse response. -2.39e+11. In the year 2009, what is the difference between the Trade (in US$) of Cambodia and Trade (in US$) of Vanuatu?
Provide a succinct answer. 4.82e+09. In the year 2009, what is the difference between the Trade (in US$) in Mexico and Trade (in US$) in Vanuatu?
Provide a succinct answer. 2.44e+11. In the year 2010, what is the difference between the Trade (in US$) of Arab World and Trade (in US$) of Cambodia?
Keep it short and to the point. 1.02e+12. In the year 2010, what is the difference between the Trade (in US$) in Arab World and Trade (in US$) in Mexico?
Provide a short and direct response. 7.17e+11. In the year 2010, what is the difference between the Trade (in US$) in Arab World and Trade (in US$) in Vanuatu?
Make the answer very short. 1.03e+12. In the year 2010, what is the difference between the Trade (in US$) of Cambodia and Trade (in US$) of Mexico?
Provide a short and direct response. -3.08e+11. In the year 2010, what is the difference between the Trade (in US$) of Cambodia and Trade (in US$) of Vanuatu?
Your response must be concise. 5.75e+09. In the year 2010, what is the difference between the Trade (in US$) in Mexico and Trade (in US$) in Vanuatu?
Your answer should be very brief. 3.14e+11. In the year 2011, what is the difference between the Trade (in US$) of Arab World and Trade (in US$) of Cambodia?
Your answer should be compact. 1.36e+12. In the year 2011, what is the difference between the Trade (in US$) in Arab World and Trade (in US$) in Mexico?
Ensure brevity in your answer.  1.00e+12. In the year 2011, what is the difference between the Trade (in US$) in Arab World and Trade (in US$) in Vanuatu?
Your response must be concise. 1.37e+12. In the year 2011, what is the difference between the Trade (in US$) in Cambodia and Trade (in US$) in Mexico?
Offer a very short reply. -3.59e+11. In the year 2011, what is the difference between the Trade (in US$) of Cambodia and Trade (in US$) of Vanuatu?
Offer a terse response. 6.59e+09. In the year 2011, what is the difference between the Trade (in US$) of Mexico and Trade (in US$) of Vanuatu?
Offer a terse response. 3.66e+11. What is the ratio of the Trade (in US$) of Arab World in 2004 to that in 2005?
Offer a terse response. 0.74. What is the ratio of the Trade (in US$) in Cambodia in 2004 to that in 2005?
Provide a short and direct response. 0.84. What is the ratio of the Trade (in US$) of Mexico in 2004 to that in 2005?
Provide a succinct answer. 0.88. What is the ratio of the Trade (in US$) in Vanuatu in 2004 to that in 2005?
Make the answer very short. 0.93. What is the ratio of the Trade (in US$) of Arab World in 2004 to that in 2006?
Give a very brief answer. 0.61. What is the ratio of the Trade (in US$) of Cambodia in 2004 to that in 2006?
Keep it short and to the point. 0.68. What is the ratio of the Trade (in US$) of Mexico in 2004 to that in 2006?
Ensure brevity in your answer.  0.76. What is the ratio of the Trade (in US$) in Vanuatu in 2004 to that in 2006?
Give a very brief answer. 0.92. What is the ratio of the Trade (in US$) of Arab World in 2004 to that in 2007?
Provide a short and direct response. 0.52. What is the ratio of the Trade (in US$) in Cambodia in 2004 to that in 2007?
Give a very brief answer. 0.6. What is the ratio of the Trade (in US$) in Mexico in 2004 to that in 2007?
Offer a terse response. 0.7. What is the ratio of the Trade (in US$) of Vanuatu in 2004 to that in 2007?
Offer a very short reply. 0.78. What is the ratio of the Trade (in US$) of Arab World in 2004 to that in 2008?
Your answer should be compact. 0.39. What is the ratio of the Trade (in US$) in Cambodia in 2004 to that in 2008?
Your answer should be very brief. 0.5. What is the ratio of the Trade (in US$) in Mexico in 2004 to that in 2008?
Provide a succinct answer. 0.66. What is the ratio of the Trade (in US$) of Vanuatu in 2004 to that in 2008?
Give a very brief answer. 0.61. What is the ratio of the Trade (in US$) of Arab World in 2004 to that in 2009?
Offer a terse response. 0.56. What is the ratio of the Trade (in US$) in Cambodia in 2004 to that in 2009?
Keep it short and to the point. 0.66. What is the ratio of the Trade (in US$) of Mexico in 2004 to that in 2009?
Provide a short and direct response. 0.83. What is the ratio of the Trade (in US$) of Vanuatu in 2004 to that in 2009?
Your response must be concise. 0.56. What is the ratio of the Trade (in US$) in Arab World in 2004 to that in 2010?
Offer a very short reply. 0.45. What is the ratio of the Trade (in US$) in Cambodia in 2004 to that in 2010?
Your answer should be very brief. 0.56. What is the ratio of the Trade (in US$) in Mexico in 2004 to that in 2010?
Offer a terse response. 0.64. What is the ratio of the Trade (in US$) in Vanuatu in 2004 to that in 2010?
Ensure brevity in your answer.  0.51. What is the ratio of the Trade (in US$) of Arab World in 2004 to that in 2011?
Offer a terse response. 0.34. What is the ratio of the Trade (in US$) of Cambodia in 2004 to that in 2011?
Keep it short and to the point. 0.49. What is the ratio of the Trade (in US$) of Mexico in 2004 to that in 2011?
Give a very brief answer. 0.55. What is the ratio of the Trade (in US$) in Vanuatu in 2004 to that in 2011?
Provide a succinct answer. 0.47. What is the ratio of the Trade (in US$) of Arab World in 2005 to that in 2006?
Make the answer very short. 0.82. What is the ratio of the Trade (in US$) in Cambodia in 2005 to that in 2006?
Offer a terse response. 0.81. What is the ratio of the Trade (in US$) in Mexico in 2005 to that in 2006?
Provide a short and direct response. 0.86. What is the ratio of the Trade (in US$) in Vanuatu in 2005 to that in 2006?
Offer a terse response. 0.99. What is the ratio of the Trade (in US$) in Arab World in 2005 to that in 2007?
Offer a very short reply. 0.7. What is the ratio of the Trade (in US$) in Cambodia in 2005 to that in 2007?
Offer a terse response. 0.71. What is the ratio of the Trade (in US$) of Mexico in 2005 to that in 2007?
Your response must be concise. 0.8. What is the ratio of the Trade (in US$) in Vanuatu in 2005 to that in 2007?
Your answer should be very brief. 0.83. What is the ratio of the Trade (in US$) of Arab World in 2005 to that in 2008?
Ensure brevity in your answer.  0.53. What is the ratio of the Trade (in US$) in Cambodia in 2005 to that in 2008?
Give a very brief answer. 0.59. What is the ratio of the Trade (in US$) in Mexico in 2005 to that in 2008?
Provide a short and direct response. 0.75. What is the ratio of the Trade (in US$) in Vanuatu in 2005 to that in 2008?
Offer a very short reply. 0.65. What is the ratio of the Trade (in US$) of Arab World in 2005 to that in 2009?
Give a very brief answer. 0.75. What is the ratio of the Trade (in US$) of Cambodia in 2005 to that in 2009?
Offer a terse response. 0.79. What is the ratio of the Trade (in US$) of Mexico in 2005 to that in 2009?
Your response must be concise. 0.94. What is the ratio of the Trade (in US$) in Vanuatu in 2005 to that in 2009?
Make the answer very short. 0.6. What is the ratio of the Trade (in US$) in Arab World in 2005 to that in 2010?
Offer a terse response. 0.61. What is the ratio of the Trade (in US$) of Cambodia in 2005 to that in 2010?
Offer a terse response. 0.66. What is the ratio of the Trade (in US$) of Mexico in 2005 to that in 2010?
Your response must be concise. 0.73. What is the ratio of the Trade (in US$) in Vanuatu in 2005 to that in 2010?
Ensure brevity in your answer.  0.55. What is the ratio of the Trade (in US$) of Arab World in 2005 to that in 2011?
Your response must be concise. 0.46. What is the ratio of the Trade (in US$) of Cambodia in 2005 to that in 2011?
Your answer should be very brief. 0.58. What is the ratio of the Trade (in US$) in Mexico in 2005 to that in 2011?
Make the answer very short. 0.63. What is the ratio of the Trade (in US$) of Vanuatu in 2005 to that in 2011?
Your response must be concise. 0.51. What is the ratio of the Trade (in US$) of Arab World in 2006 to that in 2007?
Keep it short and to the point. 0.86. What is the ratio of the Trade (in US$) of Cambodia in 2006 to that in 2007?
Give a very brief answer. 0.88. What is the ratio of the Trade (in US$) in Mexico in 2006 to that in 2007?
Keep it short and to the point. 0.92. What is the ratio of the Trade (in US$) of Vanuatu in 2006 to that in 2007?
Offer a terse response. 0.84. What is the ratio of the Trade (in US$) in Arab World in 2006 to that in 2008?
Give a very brief answer. 0.64. What is the ratio of the Trade (in US$) in Cambodia in 2006 to that in 2008?
Provide a short and direct response. 0.74. What is the ratio of the Trade (in US$) in Mexico in 2006 to that in 2008?
Make the answer very short. 0.87. What is the ratio of the Trade (in US$) in Vanuatu in 2006 to that in 2008?
Keep it short and to the point. 0.66. What is the ratio of the Trade (in US$) in Arab World in 2006 to that in 2009?
Offer a terse response. 0.92. What is the ratio of the Trade (in US$) of Cambodia in 2006 to that in 2009?
Offer a terse response. 0.97. What is the ratio of the Trade (in US$) of Mexico in 2006 to that in 2009?
Offer a very short reply. 1.09. What is the ratio of the Trade (in US$) of Vanuatu in 2006 to that in 2009?
Your answer should be compact. 0.61. What is the ratio of the Trade (in US$) in Arab World in 2006 to that in 2010?
Keep it short and to the point. 0.74. What is the ratio of the Trade (in US$) of Cambodia in 2006 to that in 2010?
Your answer should be very brief. 0.82. What is the ratio of the Trade (in US$) of Mexico in 2006 to that in 2010?
Your answer should be compact. 0.85. What is the ratio of the Trade (in US$) of Vanuatu in 2006 to that in 2010?
Provide a succinct answer. 0.55. What is the ratio of the Trade (in US$) of Arab World in 2006 to that in 2011?
Your response must be concise. 0.56. What is the ratio of the Trade (in US$) of Cambodia in 2006 to that in 2011?
Make the answer very short. 0.72. What is the ratio of the Trade (in US$) in Mexico in 2006 to that in 2011?
Make the answer very short. 0.73. What is the ratio of the Trade (in US$) in Vanuatu in 2006 to that in 2011?
Make the answer very short. 0.52. What is the ratio of the Trade (in US$) of Arab World in 2007 to that in 2008?
Ensure brevity in your answer.  0.75. What is the ratio of the Trade (in US$) of Cambodia in 2007 to that in 2008?
Keep it short and to the point. 0.83. What is the ratio of the Trade (in US$) in Mexico in 2007 to that in 2008?
Provide a succinct answer. 0.94. What is the ratio of the Trade (in US$) of Vanuatu in 2007 to that in 2008?
Make the answer very short. 0.78. What is the ratio of the Trade (in US$) of Arab World in 2007 to that in 2009?
Your response must be concise. 1.07. What is the ratio of the Trade (in US$) in Cambodia in 2007 to that in 2009?
Give a very brief answer. 1.1. What is the ratio of the Trade (in US$) of Mexico in 2007 to that in 2009?
Provide a short and direct response. 1.19. What is the ratio of the Trade (in US$) in Vanuatu in 2007 to that in 2009?
Give a very brief answer. 0.72. What is the ratio of the Trade (in US$) of Arab World in 2007 to that in 2010?
Your answer should be compact. 0.87. What is the ratio of the Trade (in US$) in Cambodia in 2007 to that in 2010?
Your answer should be very brief. 0.93. What is the ratio of the Trade (in US$) of Mexico in 2007 to that in 2010?
Offer a very short reply. 0.92. What is the ratio of the Trade (in US$) in Vanuatu in 2007 to that in 2010?
Keep it short and to the point. 0.66. What is the ratio of the Trade (in US$) of Arab World in 2007 to that in 2011?
Ensure brevity in your answer.  0.65. What is the ratio of the Trade (in US$) in Cambodia in 2007 to that in 2011?
Provide a succinct answer. 0.81. What is the ratio of the Trade (in US$) of Mexico in 2007 to that in 2011?
Ensure brevity in your answer.  0.79. What is the ratio of the Trade (in US$) in Vanuatu in 2007 to that in 2011?
Ensure brevity in your answer.  0.61. What is the ratio of the Trade (in US$) of Arab World in 2008 to that in 2009?
Keep it short and to the point. 1.43. What is the ratio of the Trade (in US$) of Cambodia in 2008 to that in 2009?
Offer a very short reply. 1.33. What is the ratio of the Trade (in US$) of Mexico in 2008 to that in 2009?
Offer a terse response. 1.26. What is the ratio of the Trade (in US$) in Vanuatu in 2008 to that in 2009?
Make the answer very short. 0.92. What is the ratio of the Trade (in US$) in Arab World in 2008 to that in 2010?
Ensure brevity in your answer.  1.16. What is the ratio of the Trade (in US$) of Cambodia in 2008 to that in 2010?
Provide a succinct answer. 1.12. What is the ratio of the Trade (in US$) of Mexico in 2008 to that in 2010?
Offer a very short reply. 0.98. What is the ratio of the Trade (in US$) in Vanuatu in 2008 to that in 2010?
Provide a short and direct response. 0.84. What is the ratio of the Trade (in US$) of Arab World in 2008 to that in 2011?
Offer a very short reply. 0.87. What is the ratio of the Trade (in US$) of Cambodia in 2008 to that in 2011?
Offer a very short reply. 0.98. What is the ratio of the Trade (in US$) in Mexico in 2008 to that in 2011?
Offer a very short reply. 0.84. What is the ratio of the Trade (in US$) in Vanuatu in 2008 to that in 2011?
Offer a terse response. 0.78. What is the ratio of the Trade (in US$) in Arab World in 2009 to that in 2010?
Offer a very short reply. 0.81. What is the ratio of the Trade (in US$) in Cambodia in 2009 to that in 2010?
Keep it short and to the point. 0.84. What is the ratio of the Trade (in US$) in Mexico in 2009 to that in 2010?
Provide a succinct answer. 0.78. What is the ratio of the Trade (in US$) in Vanuatu in 2009 to that in 2010?
Ensure brevity in your answer.  0.92. What is the ratio of the Trade (in US$) in Arab World in 2009 to that in 2011?
Your answer should be compact. 0.61. What is the ratio of the Trade (in US$) of Cambodia in 2009 to that in 2011?
Your response must be concise. 0.74. What is the ratio of the Trade (in US$) in Mexico in 2009 to that in 2011?
Ensure brevity in your answer.  0.67. What is the ratio of the Trade (in US$) in Vanuatu in 2009 to that in 2011?
Provide a succinct answer. 0.85. What is the ratio of the Trade (in US$) of Arab World in 2010 to that in 2011?
Ensure brevity in your answer.  0.75. What is the ratio of the Trade (in US$) in Cambodia in 2010 to that in 2011?
Keep it short and to the point. 0.88. What is the ratio of the Trade (in US$) in Mexico in 2010 to that in 2011?
Keep it short and to the point. 0.86. What is the ratio of the Trade (in US$) of Vanuatu in 2010 to that in 2011?
Offer a terse response. 0.93. What is the difference between the highest and the second highest Trade (in US$) of Arab World?
Give a very brief answer. 1.72e+11. What is the difference between the highest and the second highest Trade (in US$) of Cambodia?
Make the answer very short. 1.53e+08. What is the difference between the highest and the second highest Trade (in US$) in Mexico?
Provide a succinct answer. 5.22e+1. What is the difference between the highest and the second highest Trade (in US$) of Vanuatu?
Offer a very short reply. 2.45e+07. What is the difference between the highest and the lowest Trade (in US$) of Arab World?
Make the answer very short. 9.03e+11. What is the difference between the highest and the lowest Trade (in US$) of Cambodia?
Make the answer very short. 3.54e+09. What is the difference between the highest and the lowest Trade (in US$) in Mexico?
Offer a terse response. 1.64e+11. What is the difference between the highest and the lowest Trade (in US$) of Vanuatu?
Keep it short and to the point. 1.85e+08. 